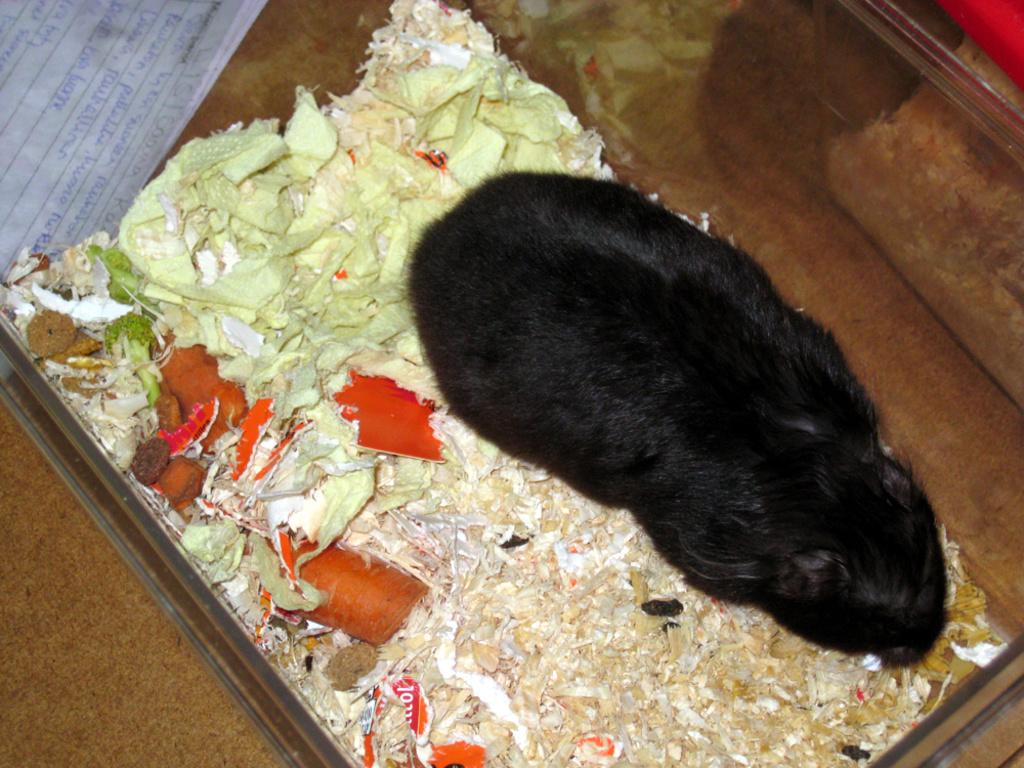What animal is in the foreground of the image? There is a rabbit in the foreground of the image. What is located near the rabbit in the image? There are vegetables on a tray in the foreground of the image. Where can a paper be found in the image? There is a paper in the top left side of the image. What type of circle can be seen in the image? There is no circle present in the image. Is there any indication of an attack in the image? There is no indication of an attack in the image. 